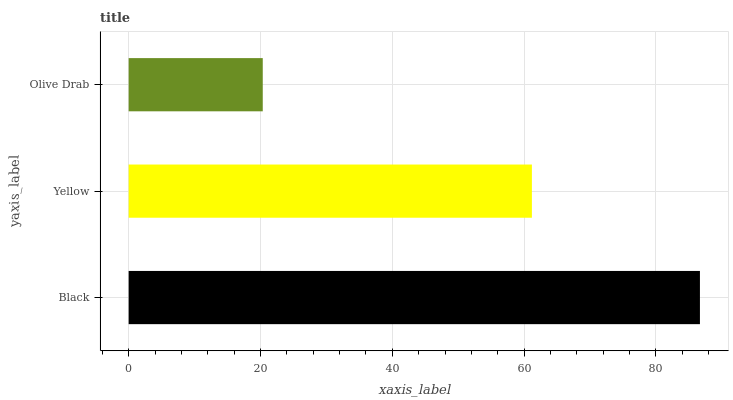Is Olive Drab the minimum?
Answer yes or no. Yes. Is Black the maximum?
Answer yes or no. Yes. Is Yellow the minimum?
Answer yes or no. No. Is Yellow the maximum?
Answer yes or no. No. Is Black greater than Yellow?
Answer yes or no. Yes. Is Yellow less than Black?
Answer yes or no. Yes. Is Yellow greater than Black?
Answer yes or no. No. Is Black less than Yellow?
Answer yes or no. No. Is Yellow the high median?
Answer yes or no. Yes. Is Yellow the low median?
Answer yes or no. Yes. Is Olive Drab the high median?
Answer yes or no. No. Is Black the low median?
Answer yes or no. No. 